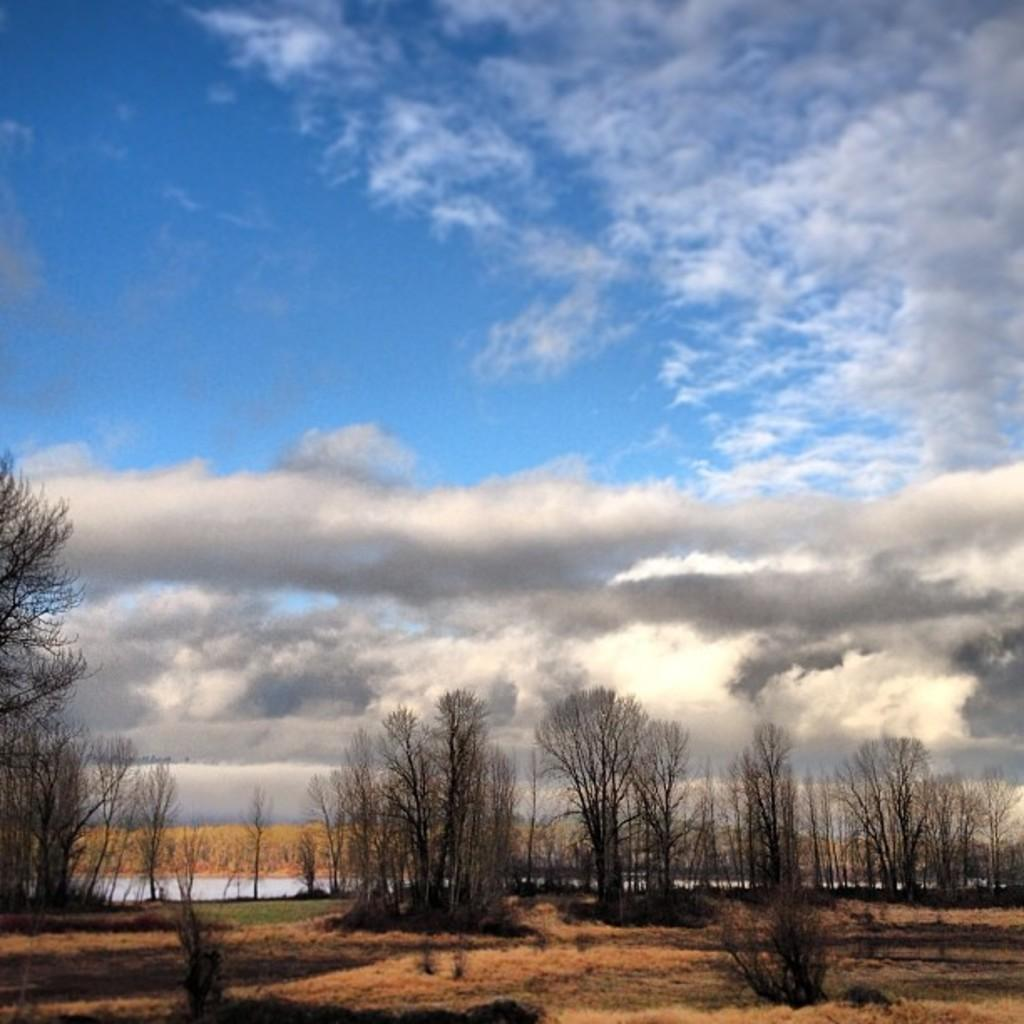What type of setting is depicted in the image? The image is an outside view. What can be seen at the bottom of the image? There are trees at the bottom of the image. What is visible in the background of the image? There is water visible in the background of the image. What is visible at the top of the image? The sky is visible at the top of the image. What can be observed in the sky? Clouds are present in the sky. What type of nation is depicted in the image? There is no nation depicted in the image; it is an outside view with trees, water, and clouds in the sky. What is the rat doing in the image? There is no rat present in the image. What is the good-bye message written on the water in the image? There is no message or text visible on the water in the image. 